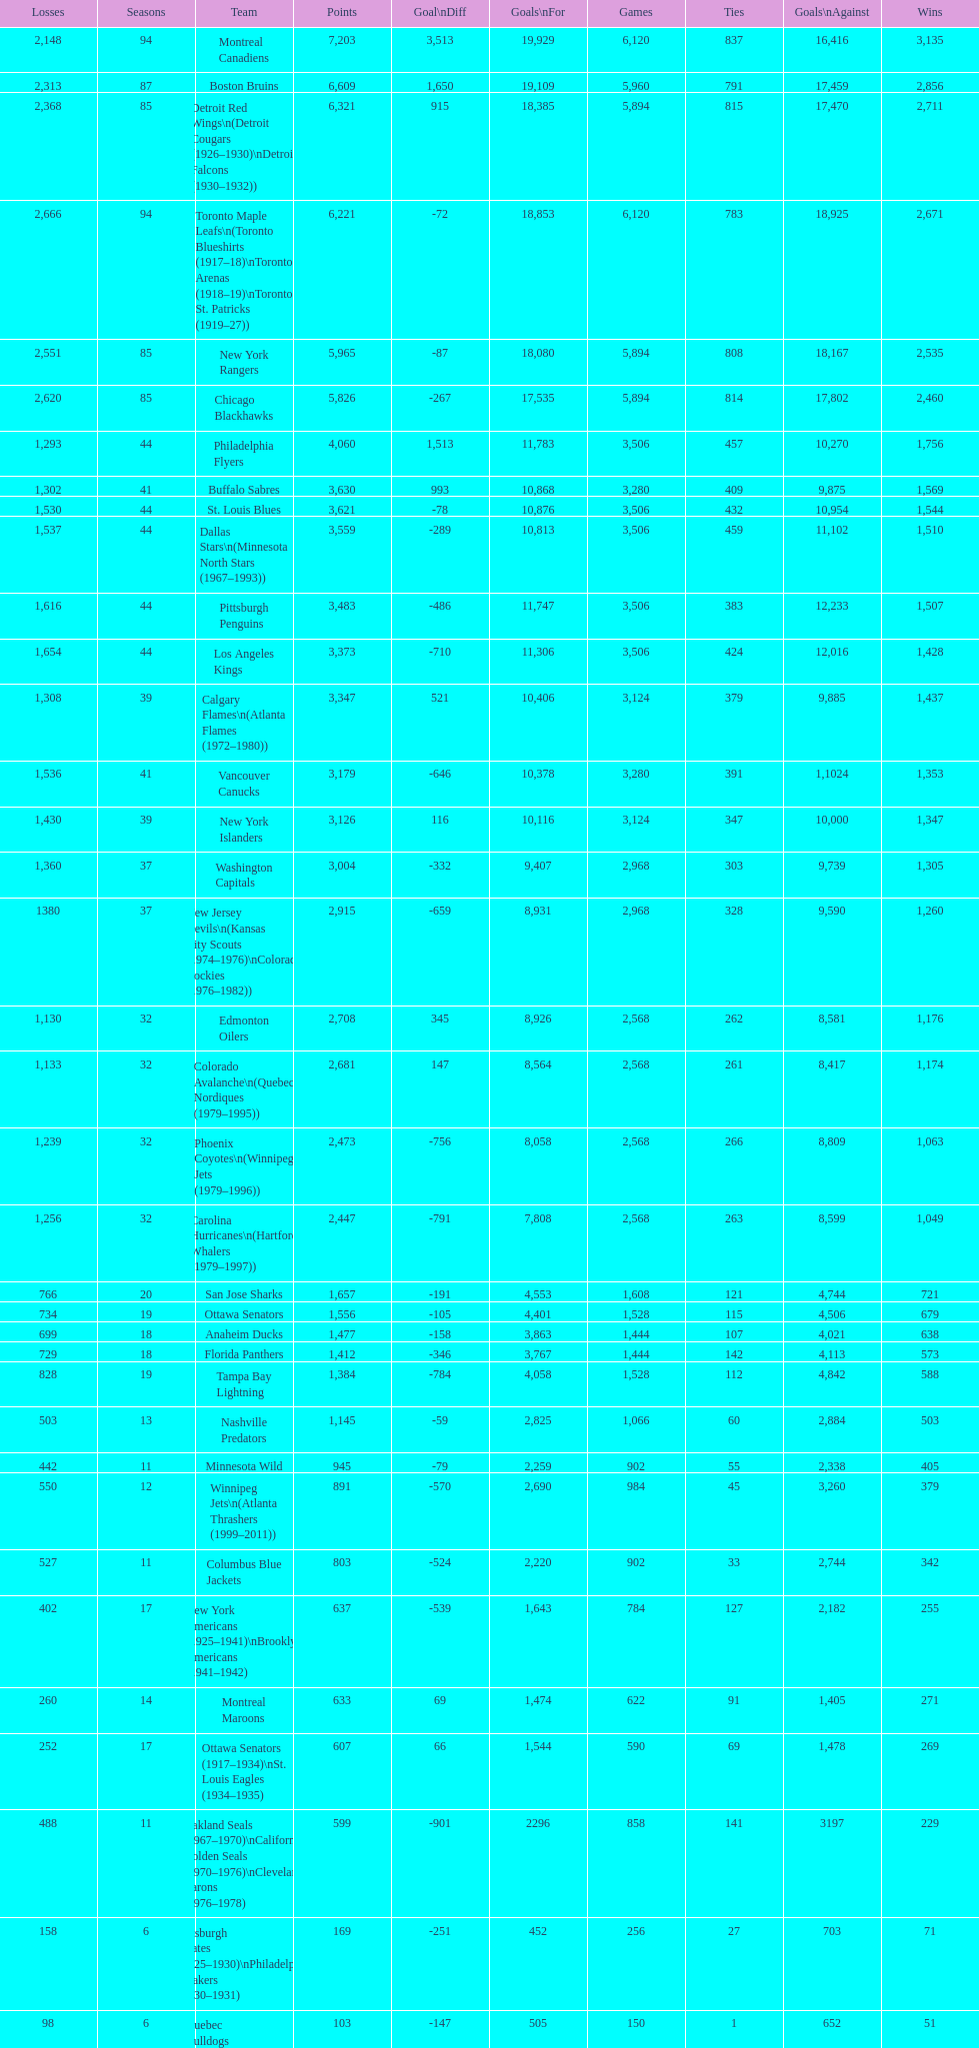Which team played the same amount of seasons as the canadiens? Toronto Maple Leafs. 